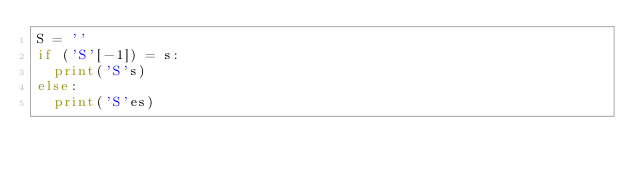Convert code to text. <code><loc_0><loc_0><loc_500><loc_500><_Python_>S = ''
if ('S'[-1]) = s:
  print('S's)
else:
  print('S'es)</code> 